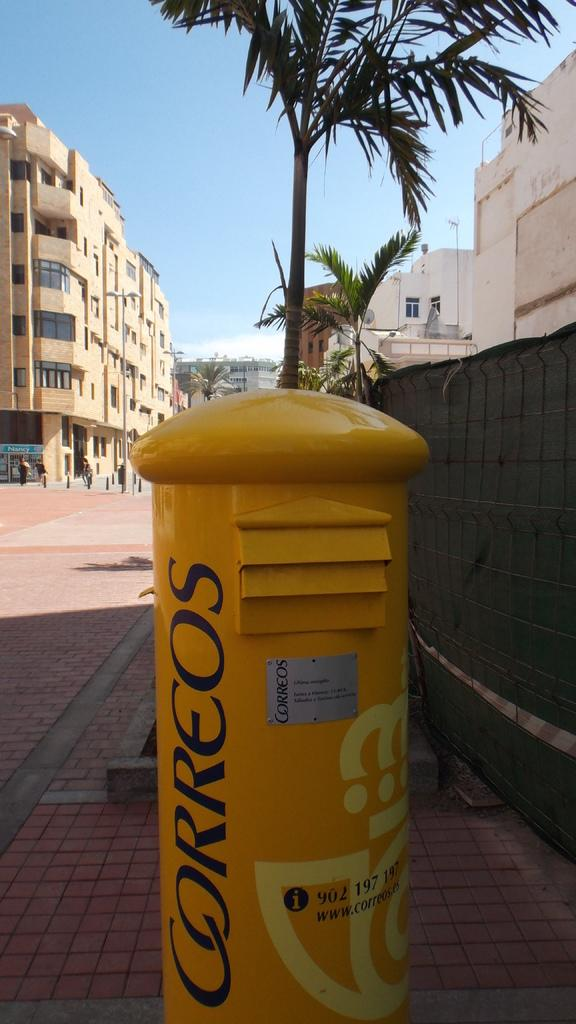<image>
Present a compact description of the photo's key features. a can on a sidewalk that says 'correos' on it 